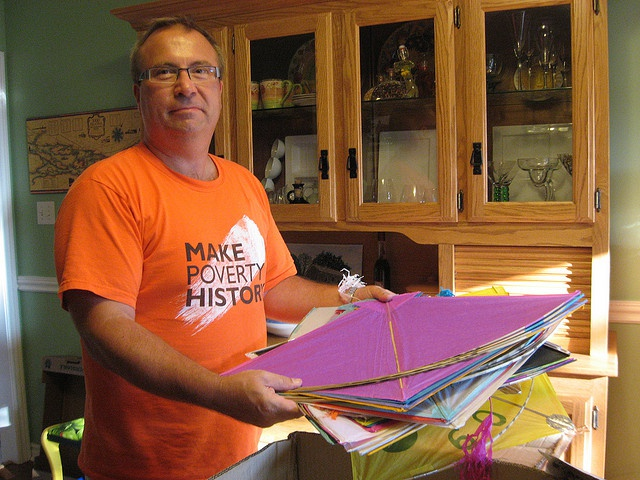Describe the objects in this image and their specific colors. I can see people in darkgreen, red, maroon, and brown tones, kite in darkgreen, magenta, violet, brown, and gray tones, kite in darkgreen, olive, tan, and gold tones, kite in darkgreen, darkgray, gray, and lightblue tones, and kite in darkgreen, black, darkgray, lightgray, and gray tones in this image. 